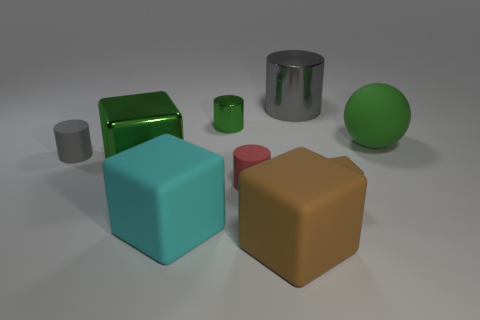Subtract all green cylinders. How many cylinders are left? 3 Add 1 red shiny objects. How many objects exist? 10 Subtract all cylinders. How many objects are left? 5 Subtract 2 cylinders. How many cylinders are left? 2 Subtract all cyan cubes. How many cubes are left? 3 Subtract all blue cylinders. How many yellow blocks are left? 0 Subtract all big brown matte cubes. Subtract all gray shiny spheres. How many objects are left? 8 Add 3 small gray things. How many small gray things are left? 4 Add 3 green things. How many green things exist? 6 Subtract 0 gray cubes. How many objects are left? 9 